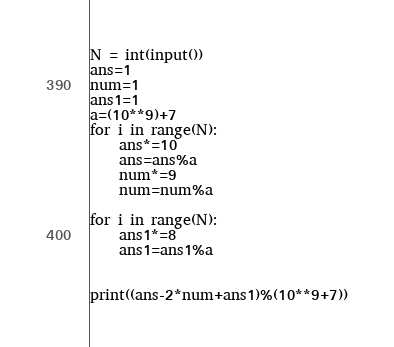Convert code to text. <code><loc_0><loc_0><loc_500><loc_500><_Python_>N = int(input())
ans=1
num=1
ans1=1
a=(10**9)+7
for i in range(N):
    ans*=10
    ans=ans%a
    num*=9
    num=num%a
    
for i in range(N):
    ans1*=8
    ans1=ans1%a


print((ans-2*num+ans1)%(10**9+7))</code> 